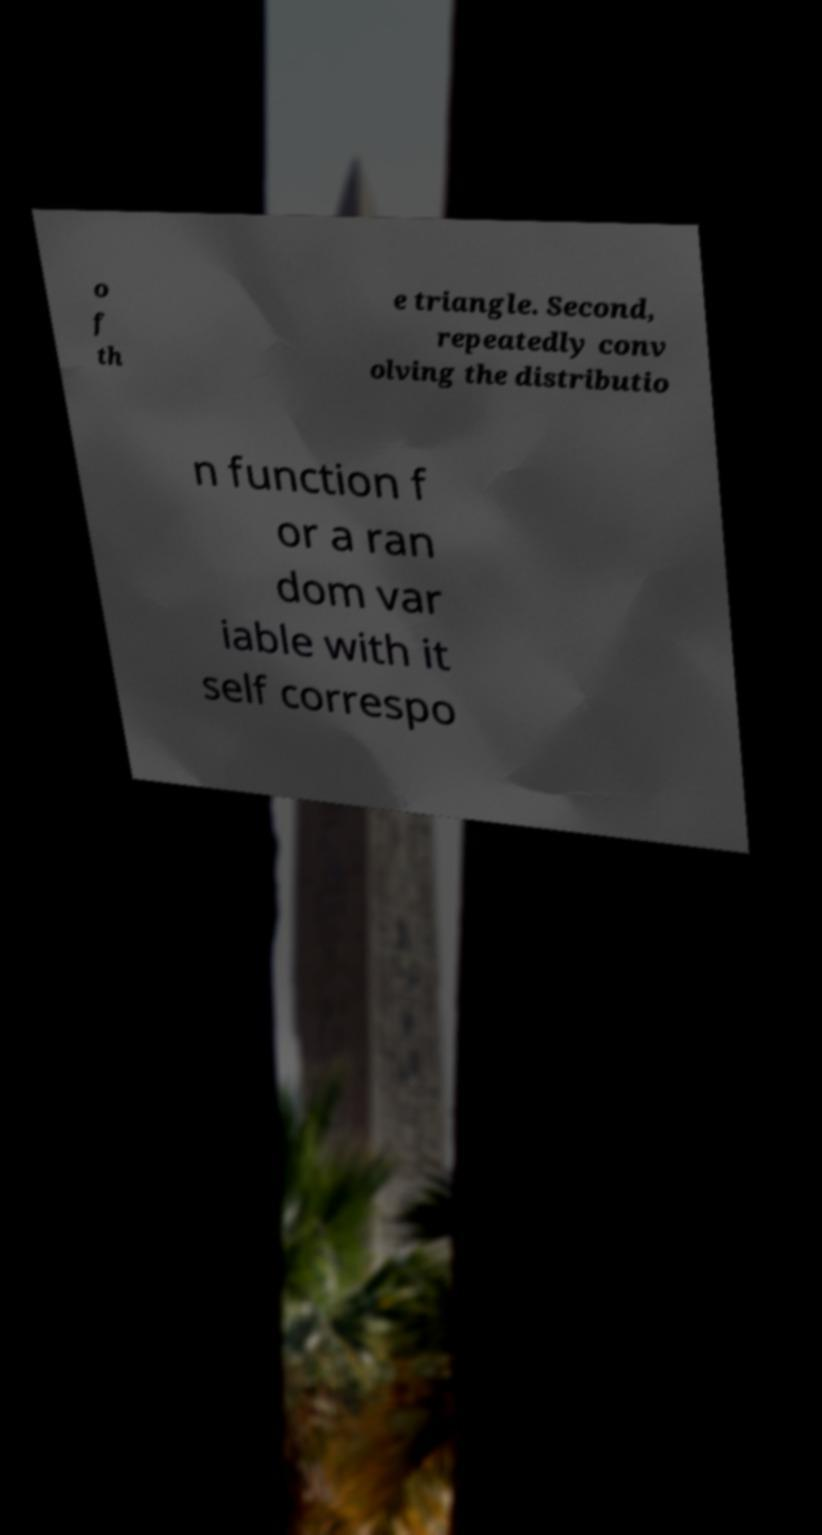Please identify and transcribe the text found in this image. o f th e triangle. Second, repeatedly conv olving the distributio n function f or a ran dom var iable with it self correspo 